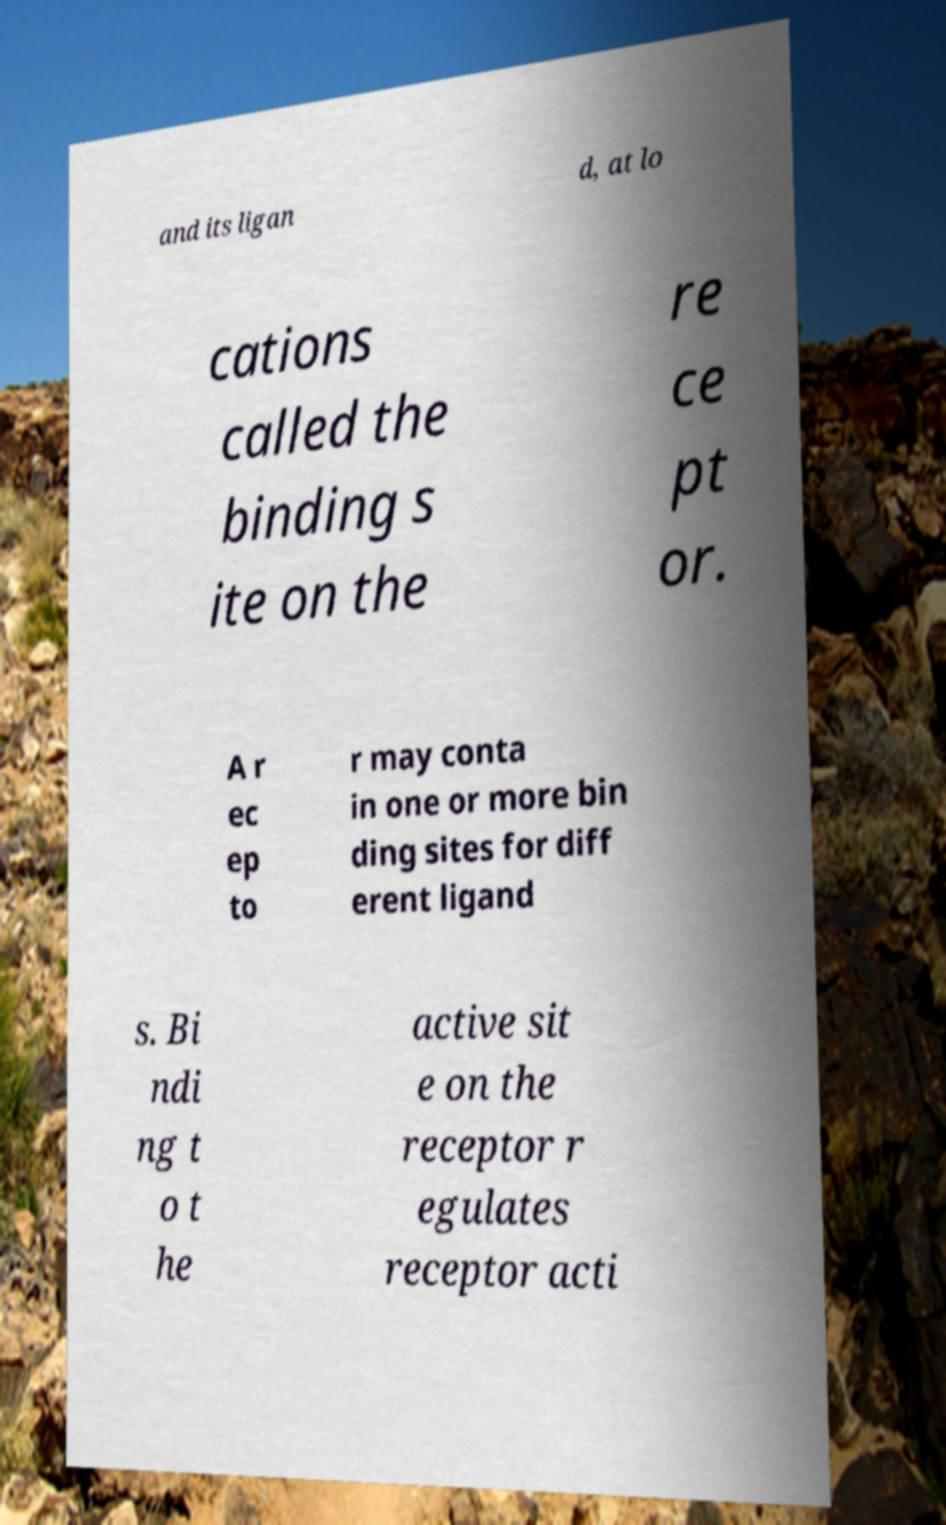Can you accurately transcribe the text from the provided image for me? and its ligan d, at lo cations called the binding s ite on the re ce pt or. A r ec ep to r may conta in one or more bin ding sites for diff erent ligand s. Bi ndi ng t o t he active sit e on the receptor r egulates receptor acti 